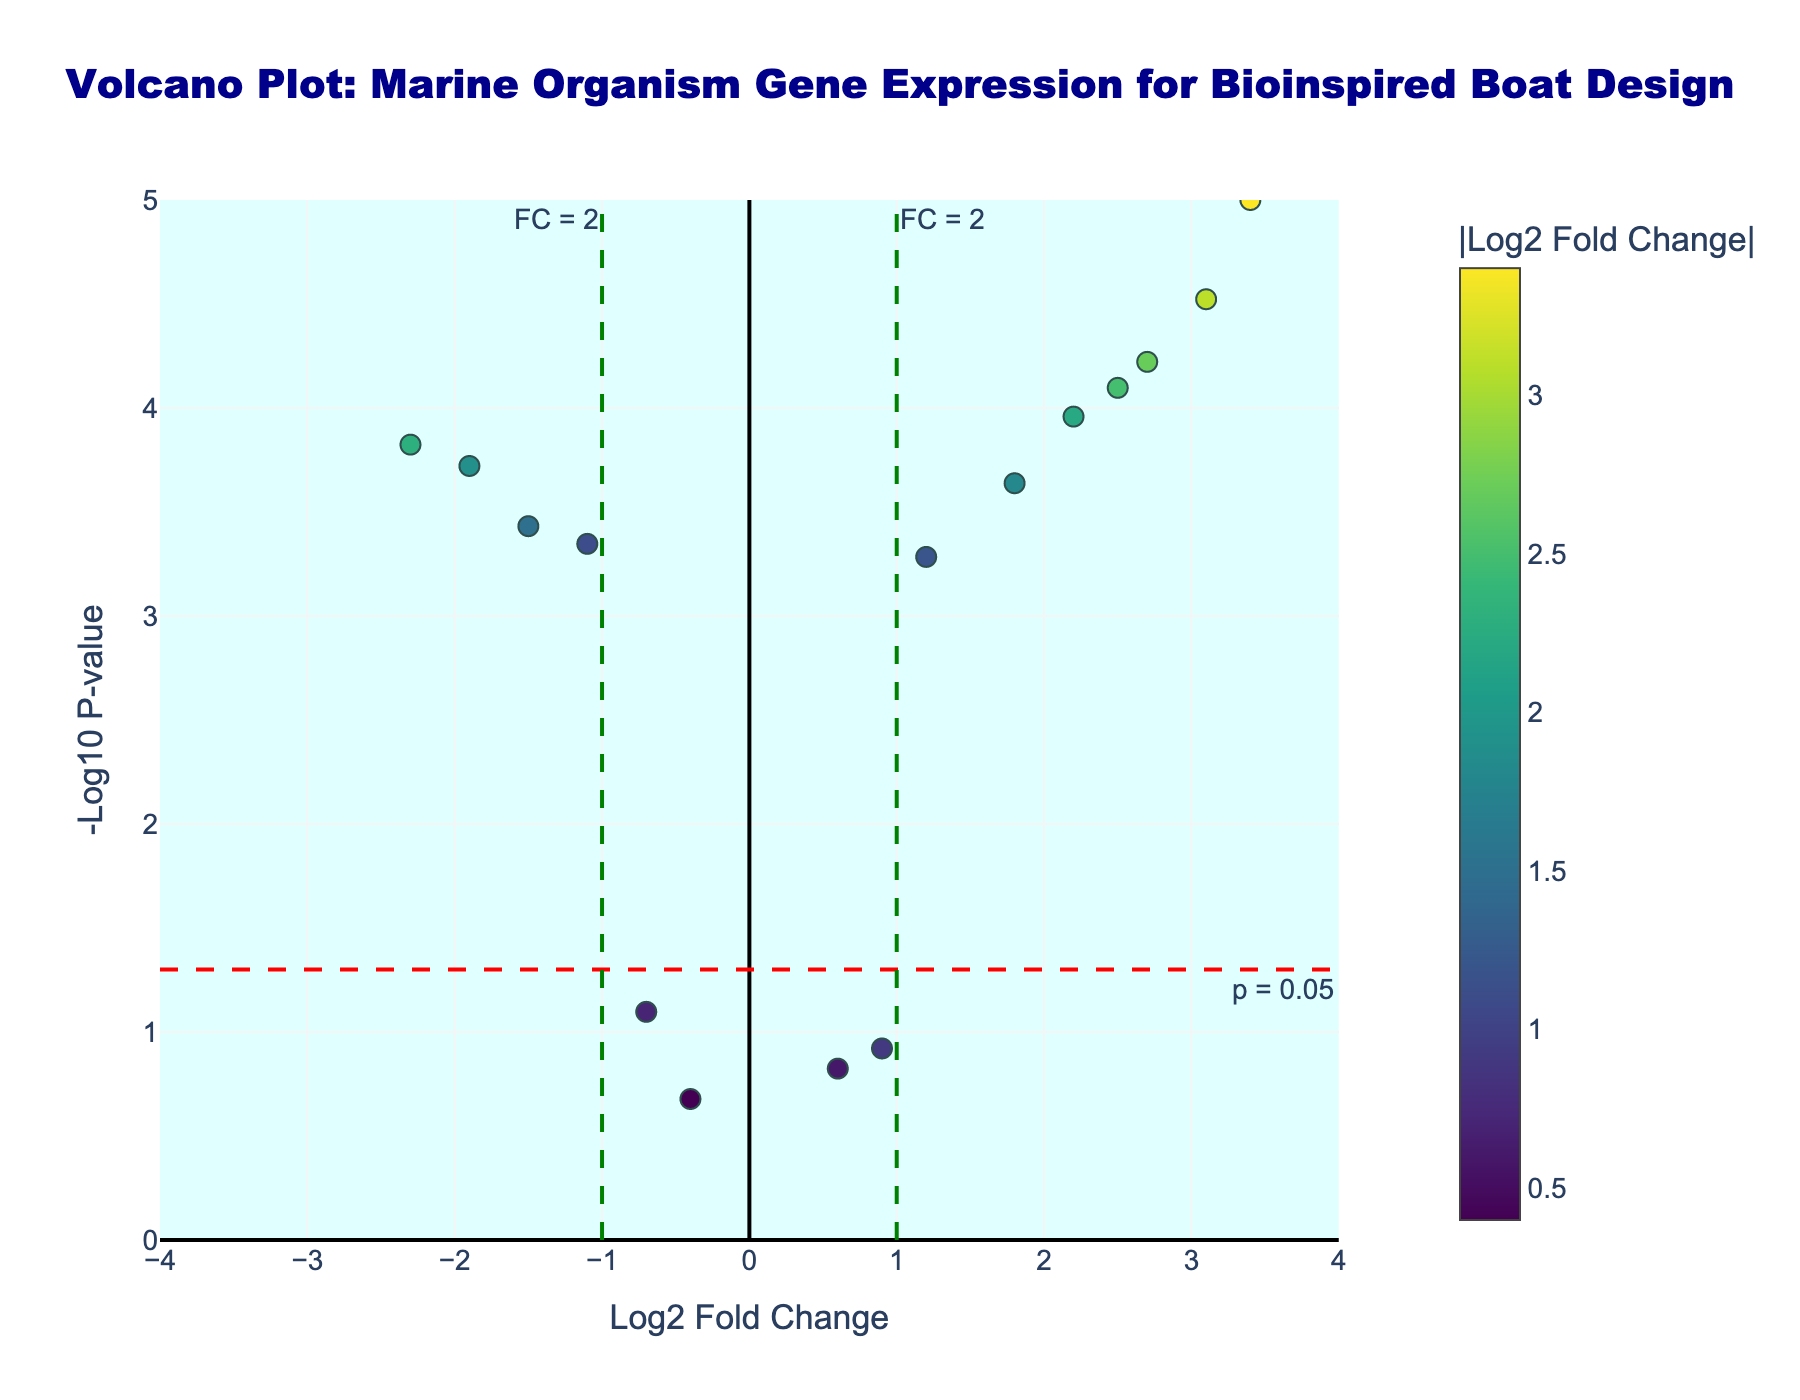How many genes have both a significant p-value (p < 0.05) and a log2 fold change greater than 1? First, observe the vertical dashed green line at log2 fold change of 1.0 to identify genes with fold changes greater than 1. Then, count the number of points above the horizontal dashed red line at -log10(p-value) corresponding to p = 0.05. There are 7 such genes: Dragline_Silk_Protein, Titin, Byssal_Thread_Protein, Chitin_Synthase, Spongin, Collagen_Type_I, and Fibronectin.
Answer: 7 Which gene has the highest log2 fold change? Look at the points to determine the gene farthest to the right. The gene with the highest log2 fold change is Dragline_Silk_Protein with a log2 fold change of 3.4.
Answer: Dragline_Silk_Protein What is the log2 fold change of Elastin? Locate the point corresponding to the gene Elastin in the middle left. The log2 fold change for Elastin is indicated at approximately -1.5.
Answer: -1.5 How many genes show a down-regulation with significant p-values? Identify the genes with negative log2 fold changes (to the left of zero) and a -log10(p-value) above the significance threshold (horizontal red dashed line). There are 4 such genes: Myosin_Heavy_Chain, Elastin, Resilin, and Nacre_Matrix_Protein.
Answer: 4 Which gene has the smallest p-value and what is its log2 fold change? Identify the point highest up the y-axis. This corresponds to Dragline_Silk_Protein with a log2 fold change of 3.4 and the smallest p-value.
Answer: Dragline_Silk_Protein, 3.4 Which two genes have log2 fold changes closest to zero and are not significant? Identify the points around the position where the vertical dashed lines meet the horizontal axis at zero, but below the horizontal red dashed line. These two genes are Laminin and Actin_Filament.
Answer: Laminin and Actin_Filament What is the -log10(p-value) for Myosin_Heavy_Chain? Find Myosin_Heavy_Chain point, which is towards the left. The -log10(p-value) axis indicates a value of approximately 3.8 based on the y-axis.
Answer: ~3.8 Between Spongin and Byssal_Thread_Protein, which one has a higher -log10(p-value)? Compare the y-axis positions of the points representing Spongin and Byssal_Thread_Protein. The point for Spongin is higher, indicating a higher -log10(p-value).
Answer: Spongin How many genes have a log2 fold change greater than 2? Count the number of points to the right of the vertical green dashed line representing a log2 fold change of 2. There are four genes: Chitin_Synthase, Titin, Dragline_Silk_Protein, and Spongin.
Answer: 4 What is the primary color theme of the plot? Observe the overall color scheme used for the data points. The plot uses a colorscale ranging from light to dark in shades of green and yellow from the Viridis color palette.
Answer: Viridis 